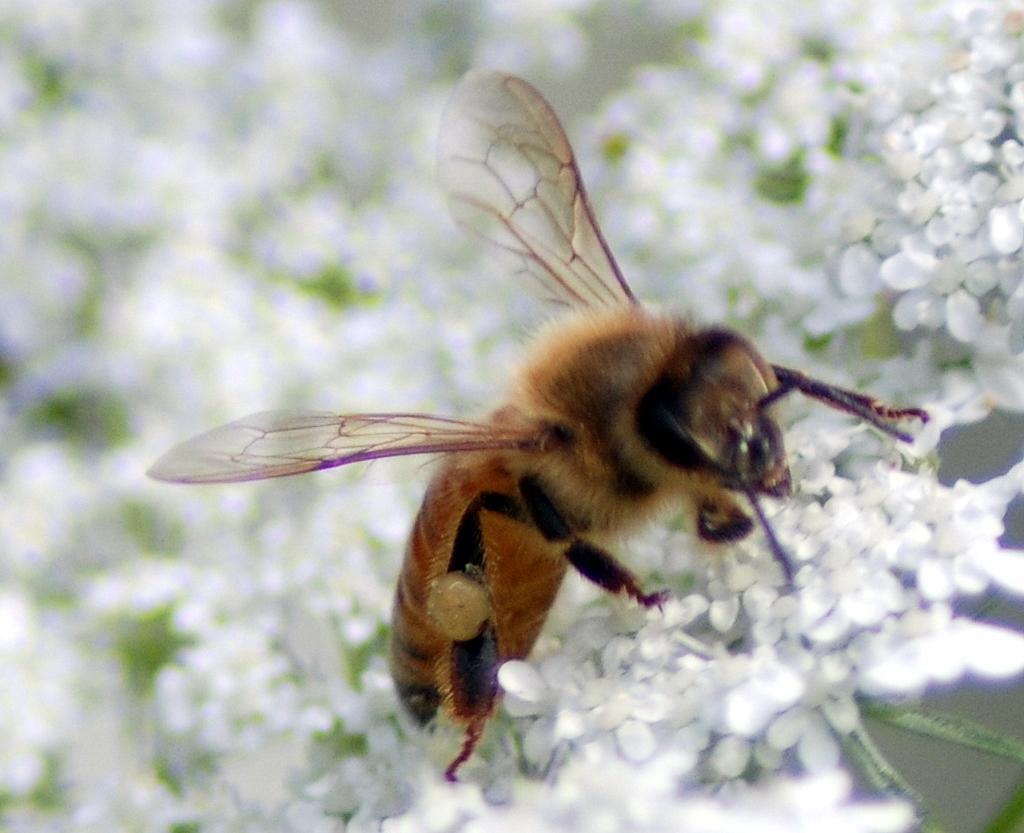Can you describe this image briefly? In this image, we can see an insect on some flowers. 